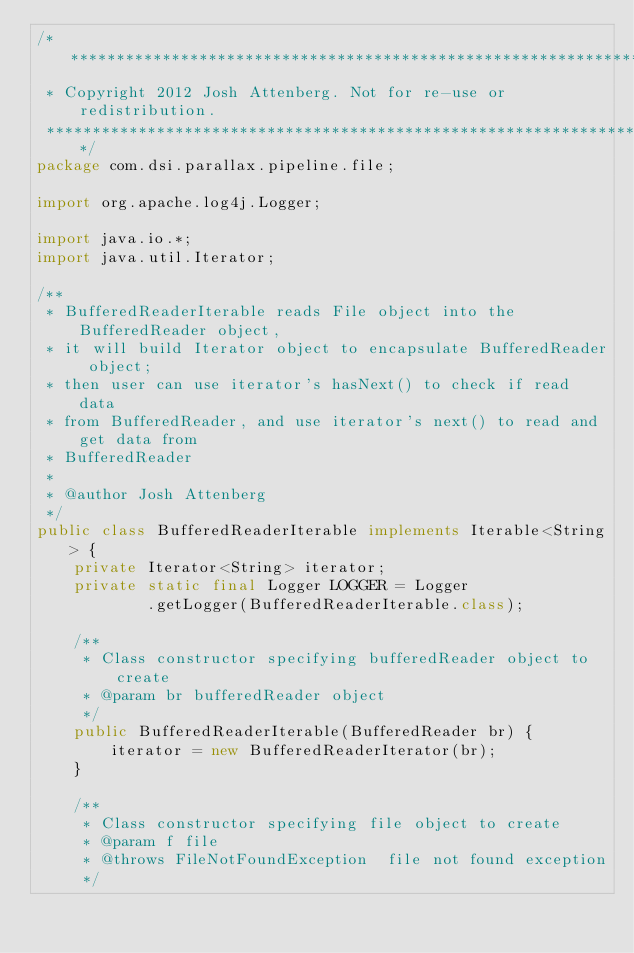<code> <loc_0><loc_0><loc_500><loc_500><_Java_>/*******************************************************************************
 * Copyright 2012 Josh Attenberg. Not for re-use or redistribution.
 ******************************************************************************/
package com.dsi.parallax.pipeline.file;

import org.apache.log4j.Logger;

import java.io.*;
import java.util.Iterator;

/**
 * BufferedReaderIterable reads File object into the BufferedReader object, 
 * it will build Iterator object to encapsulate BufferedReader object; 
 * then user can use iterator's hasNext() to check if read data
 * from BufferedReader, and use iterator's next() to read and get data from 
 * BufferedReader
 *
 * @author Josh Attenberg
 */
public class BufferedReaderIterable implements Iterable<String> {
    private Iterator<String> iterator;
    private static final Logger LOGGER = Logger
            .getLogger(BufferedReaderIterable.class);

    /**
     * Class constructor specifying bufferedReader object to create
     * @param br bufferedReader object
     */
    public BufferedReaderIterable(BufferedReader br) {
        iterator = new BufferedReaderIterator(br);
    }

    /**
     * Class constructor specifying file object to create
     * @param f file
     * @throws FileNotFoundException  file not found exception
     */</code> 